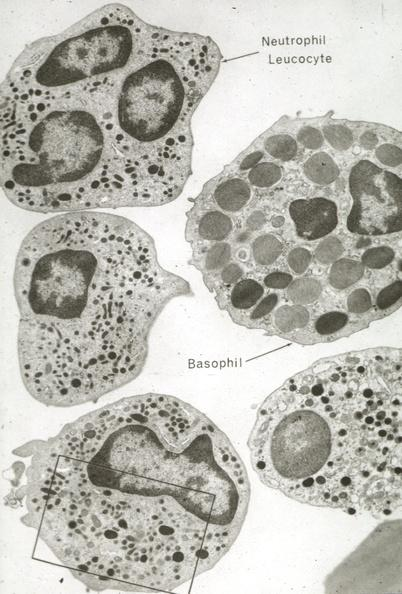s hyalin mass in pituitary which is amyloid there are several slides from this case in this file 23 yowf amyloid limited to brain present?
Answer the question using a single word or phrase. No 